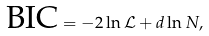<formula> <loc_0><loc_0><loc_500><loc_500>\text {BIC} = - 2 \ln { \mathcal { L } } + d \ln { N } ,</formula> 